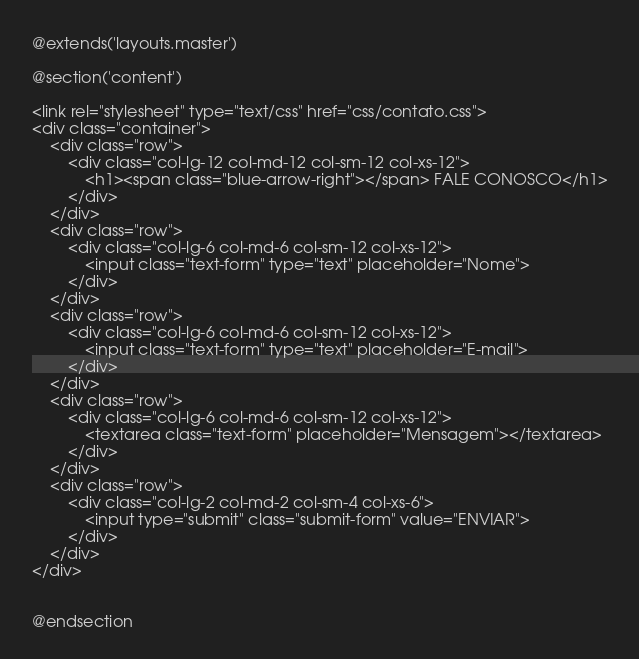Convert code to text. <code><loc_0><loc_0><loc_500><loc_500><_PHP_>@extends('layouts.master')

@section('content')

<link rel="stylesheet" type="text/css" href="css/contato.css">
<div class="container">
	<div class="row">
		<div class="col-lg-12 col-md-12 col-sm-12 col-xs-12">
			<h1><span class="blue-arrow-right"></span> FALE CONOSCO</h1>
		</div>
	</div>
	<div class="row">
		<div class="col-lg-6 col-md-6 col-sm-12 col-xs-12">
			<input class="text-form" type="text" placeholder="Nome">
		</div>
	</div>
	<div class="row">
		<div class="col-lg-6 col-md-6 col-sm-12 col-xs-12">
			<input class="text-form" type="text" placeholder="E-mail">
		</div>
	</div>
	<div class="row">
		<div class="col-lg-6 col-md-6 col-sm-12 col-xs-12">
			<textarea class="text-form" placeholder="Mensagem"></textarea>
		</div>
	</div>
	<div class="row">
		<div class="col-lg-2 col-md-2 col-sm-4 col-xs-6">
			<input type="submit" class="submit-form" value="ENVIAR">
		</div>
	</div>
</div>


@endsection</code> 